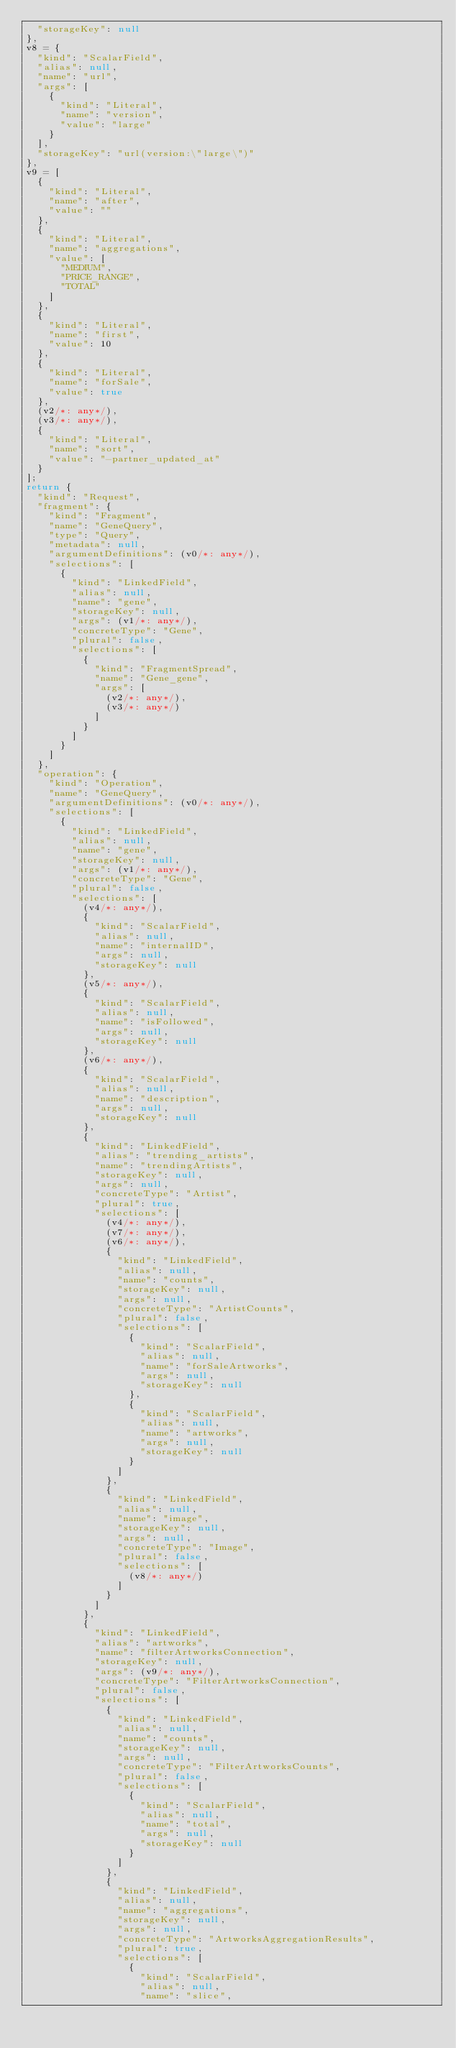Convert code to text. <code><loc_0><loc_0><loc_500><loc_500><_TypeScript_>  "storageKey": null
},
v8 = {
  "kind": "ScalarField",
  "alias": null,
  "name": "url",
  "args": [
    {
      "kind": "Literal",
      "name": "version",
      "value": "large"
    }
  ],
  "storageKey": "url(version:\"large\")"
},
v9 = [
  {
    "kind": "Literal",
    "name": "after",
    "value": ""
  },
  {
    "kind": "Literal",
    "name": "aggregations",
    "value": [
      "MEDIUM",
      "PRICE_RANGE",
      "TOTAL"
    ]
  },
  {
    "kind": "Literal",
    "name": "first",
    "value": 10
  },
  {
    "kind": "Literal",
    "name": "forSale",
    "value": true
  },
  (v2/*: any*/),
  (v3/*: any*/),
  {
    "kind": "Literal",
    "name": "sort",
    "value": "-partner_updated_at"
  }
];
return {
  "kind": "Request",
  "fragment": {
    "kind": "Fragment",
    "name": "GeneQuery",
    "type": "Query",
    "metadata": null,
    "argumentDefinitions": (v0/*: any*/),
    "selections": [
      {
        "kind": "LinkedField",
        "alias": null,
        "name": "gene",
        "storageKey": null,
        "args": (v1/*: any*/),
        "concreteType": "Gene",
        "plural": false,
        "selections": [
          {
            "kind": "FragmentSpread",
            "name": "Gene_gene",
            "args": [
              (v2/*: any*/),
              (v3/*: any*/)
            ]
          }
        ]
      }
    ]
  },
  "operation": {
    "kind": "Operation",
    "name": "GeneQuery",
    "argumentDefinitions": (v0/*: any*/),
    "selections": [
      {
        "kind": "LinkedField",
        "alias": null,
        "name": "gene",
        "storageKey": null,
        "args": (v1/*: any*/),
        "concreteType": "Gene",
        "plural": false,
        "selections": [
          (v4/*: any*/),
          {
            "kind": "ScalarField",
            "alias": null,
            "name": "internalID",
            "args": null,
            "storageKey": null
          },
          (v5/*: any*/),
          {
            "kind": "ScalarField",
            "alias": null,
            "name": "isFollowed",
            "args": null,
            "storageKey": null
          },
          (v6/*: any*/),
          {
            "kind": "ScalarField",
            "alias": null,
            "name": "description",
            "args": null,
            "storageKey": null
          },
          {
            "kind": "LinkedField",
            "alias": "trending_artists",
            "name": "trendingArtists",
            "storageKey": null,
            "args": null,
            "concreteType": "Artist",
            "plural": true,
            "selections": [
              (v4/*: any*/),
              (v7/*: any*/),
              (v6/*: any*/),
              {
                "kind": "LinkedField",
                "alias": null,
                "name": "counts",
                "storageKey": null,
                "args": null,
                "concreteType": "ArtistCounts",
                "plural": false,
                "selections": [
                  {
                    "kind": "ScalarField",
                    "alias": null,
                    "name": "forSaleArtworks",
                    "args": null,
                    "storageKey": null
                  },
                  {
                    "kind": "ScalarField",
                    "alias": null,
                    "name": "artworks",
                    "args": null,
                    "storageKey": null
                  }
                ]
              },
              {
                "kind": "LinkedField",
                "alias": null,
                "name": "image",
                "storageKey": null,
                "args": null,
                "concreteType": "Image",
                "plural": false,
                "selections": [
                  (v8/*: any*/)
                ]
              }
            ]
          },
          {
            "kind": "LinkedField",
            "alias": "artworks",
            "name": "filterArtworksConnection",
            "storageKey": null,
            "args": (v9/*: any*/),
            "concreteType": "FilterArtworksConnection",
            "plural": false,
            "selections": [
              {
                "kind": "LinkedField",
                "alias": null,
                "name": "counts",
                "storageKey": null,
                "args": null,
                "concreteType": "FilterArtworksCounts",
                "plural": false,
                "selections": [
                  {
                    "kind": "ScalarField",
                    "alias": null,
                    "name": "total",
                    "args": null,
                    "storageKey": null
                  }
                ]
              },
              {
                "kind": "LinkedField",
                "alias": null,
                "name": "aggregations",
                "storageKey": null,
                "args": null,
                "concreteType": "ArtworksAggregationResults",
                "plural": true,
                "selections": [
                  {
                    "kind": "ScalarField",
                    "alias": null,
                    "name": "slice",</code> 